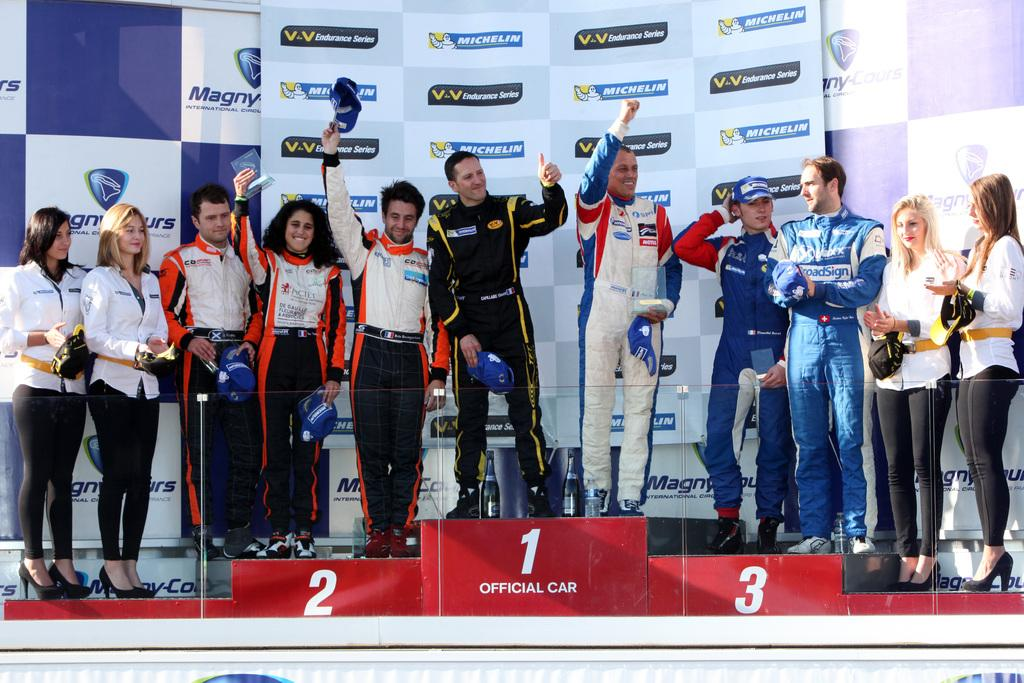<image>
Summarize the visual content of the image. people standing on a red podium labeled 1 official car, 2, 3 